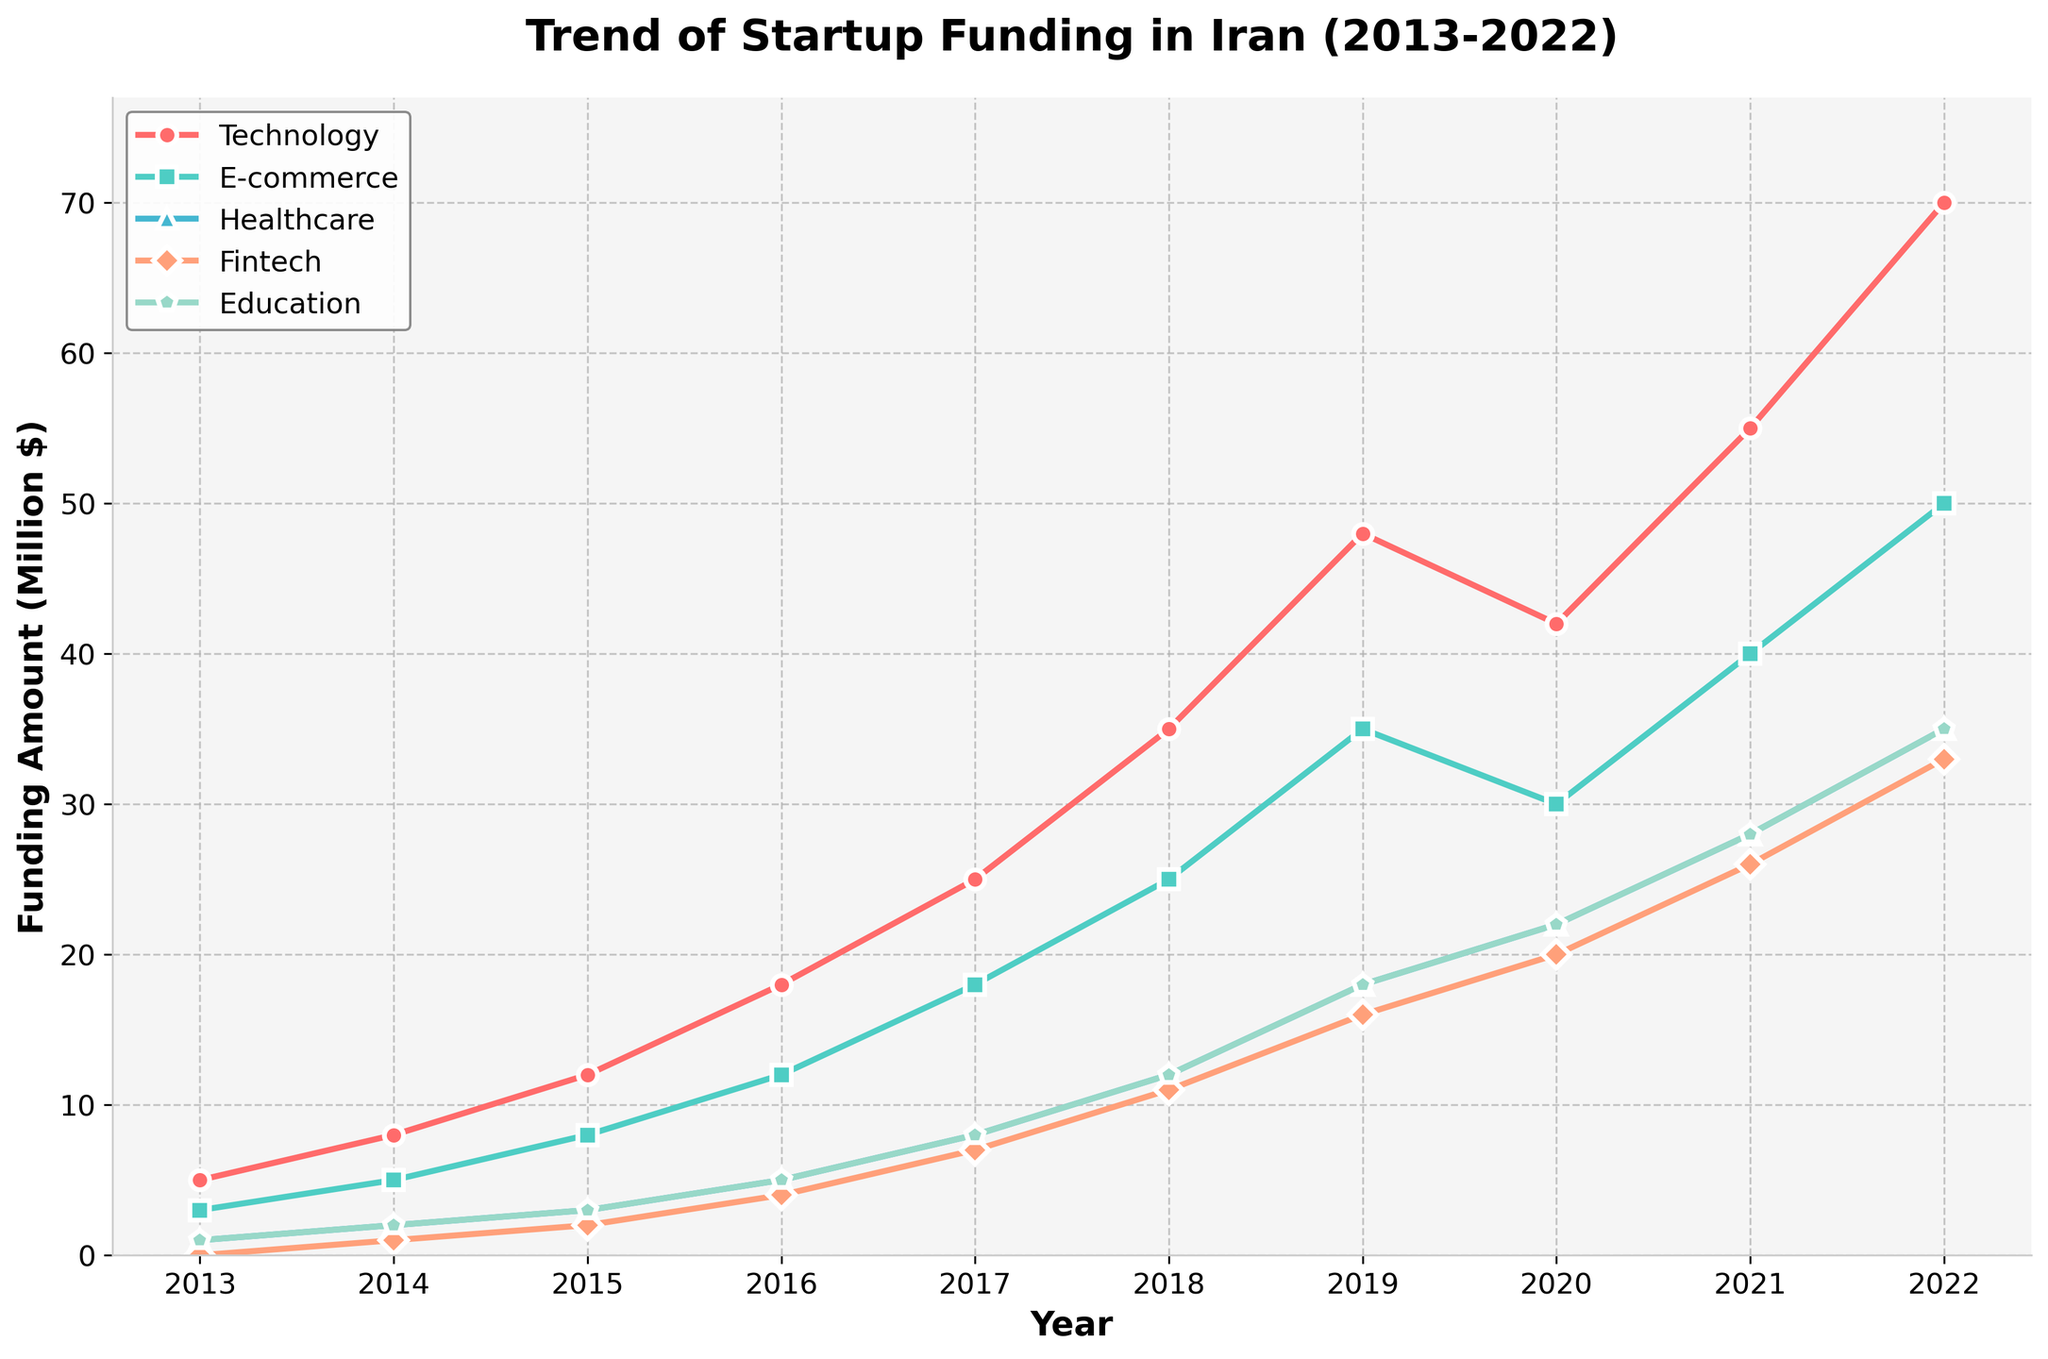What's the peak funding year for the Technology sector? The line for the Technology sector reaches its highest point in the year 2022, which is where the funding amount is the greatest on the chart.
Answer: 2022 Which sector shows the most consistent growth over the years? By observing the slopes of the lines, the Technology sector shows a consistent and steep increase in funding each year compared to other sectors, which may have flatter sections or dips.
Answer: Technology How many times did Fintech funding equal or surpass Healthcare funding over the decade? Examining the points where the Fintech line crosses the Healthcare line, Fintech surpasses Healthcare funding from 2019 onwards, giving us three instances (2019, 2020, 2021, 2022).
Answer: 4 In which year did E-commerce funding surpass 20 million dollars? By finding the point where the E-commerce line crosses the 20 million dollar mark, we see that it happens in the year 2018.
Answer: 2018 What is the total funding for the Education sector over the decade? Summing the funding amounts for the Education sector from each year: 1 + 2 + 3 + 5 + 8 + 12 + 18 + 22 + 28 + 35 = 134 million dollars.
Answer: 134 million dollars Between which consecutive years did Healthcare funding see the biggest increase? Calculating the year-to-year differences for Healthcare funding, the biggest increase is between 2015 (3) to 2016 (5), a change of 2 million dollars.
Answer: 2015 to 2016 Which sector had the longest period without an increase in funding? Observing the trends, the Technology sector never shows a decrease, while Fintech shows a long plateau from 2019 to 2020.
Answer: Fintech Compare the difference in the funding amount between Technology and Healthcare in 2022. The funding for Technology in 2022 is 70 million dollars, and for Healthcare, it's 35 million dollars. The difference is 70 - 35 = 35 million dollars.
Answer: 35 million dollars Was there any year when all the sectors increased in funding compared to the previous year? Checking each year consecutively, there isn't a single year where every sector shows an increase.
Answer: No What's the visual pattern of the E-commerce sector's growth in funding? The E-commerce sector shows a steady increase each year with a particularly marked growth spurt between 2016 and 2017. It's represented by a green line with square markers.
Answer: Steady growth with a spurt between 2016 and 2017 